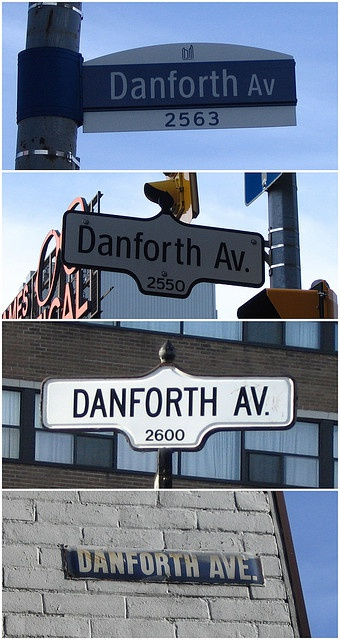Describe the objects in this image and their specific colors. I can see a traffic light in white, black, olive, and maroon tones in this image. 